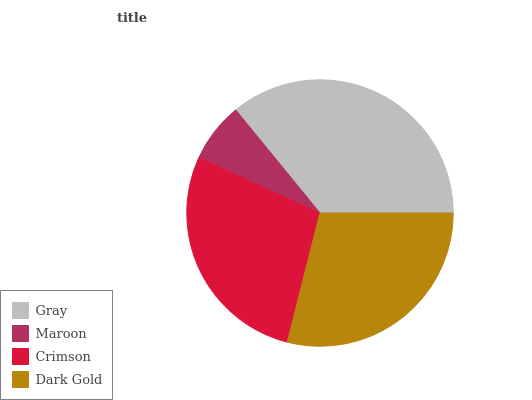Is Maroon the minimum?
Answer yes or no. Yes. Is Gray the maximum?
Answer yes or no. Yes. Is Crimson the minimum?
Answer yes or no. No. Is Crimson the maximum?
Answer yes or no. No. Is Crimson greater than Maroon?
Answer yes or no. Yes. Is Maroon less than Crimson?
Answer yes or no. Yes. Is Maroon greater than Crimson?
Answer yes or no. No. Is Crimson less than Maroon?
Answer yes or no. No. Is Dark Gold the high median?
Answer yes or no. Yes. Is Crimson the low median?
Answer yes or no. Yes. Is Crimson the high median?
Answer yes or no. No. Is Gray the low median?
Answer yes or no. No. 